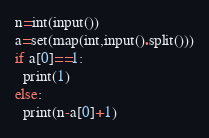Convert code to text. <code><loc_0><loc_0><loc_500><loc_500><_Python_>n=int(input())
a=set(map(int,input().split()))
if a[0]==1:
  print(1)
else:
  print(n-a[0]+1)
</code> 